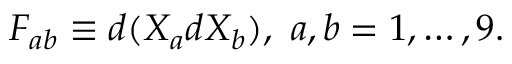<formula> <loc_0><loc_0><loc_500><loc_500>F _ { a b } \equiv d ( X _ { a } d X _ { b } ) , \, a , b = 1 , \dots , 9 .</formula> 